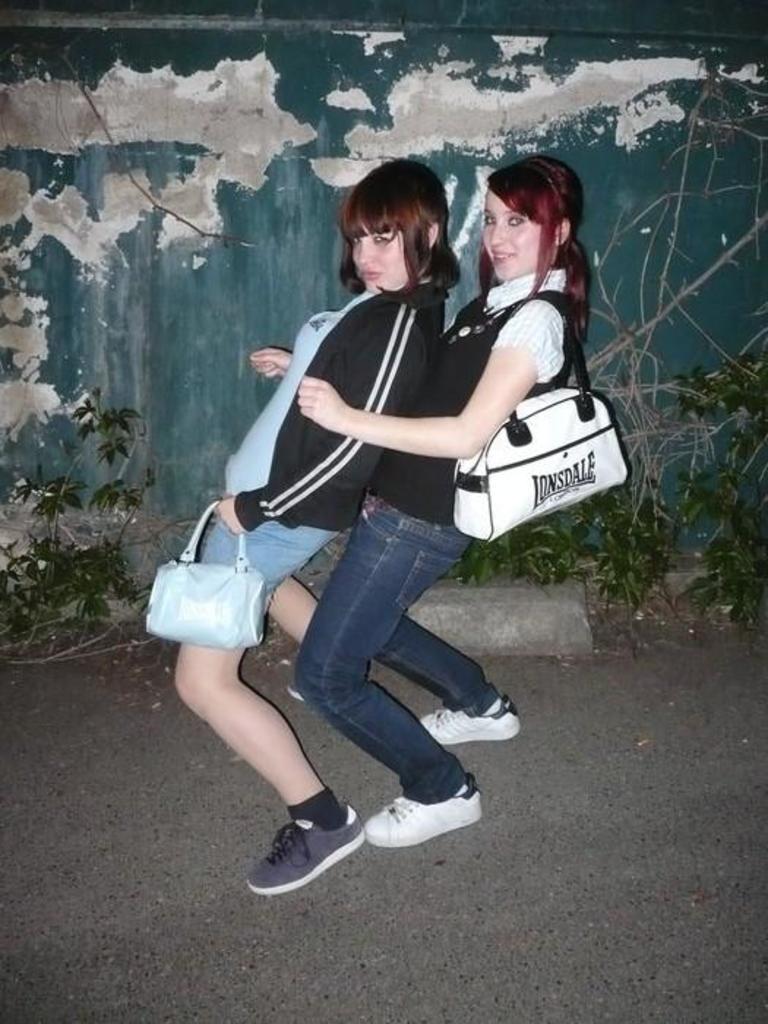Could you give a brief overview of what you see in this image? In this image I can see two people wearing the shoes and holding the bags. In the background there are some plants and a wall. 